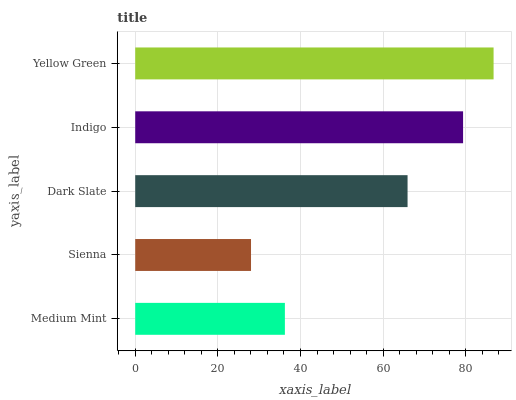Is Sienna the minimum?
Answer yes or no. Yes. Is Yellow Green the maximum?
Answer yes or no. Yes. Is Dark Slate the minimum?
Answer yes or no. No. Is Dark Slate the maximum?
Answer yes or no. No. Is Dark Slate greater than Sienna?
Answer yes or no. Yes. Is Sienna less than Dark Slate?
Answer yes or no. Yes. Is Sienna greater than Dark Slate?
Answer yes or no. No. Is Dark Slate less than Sienna?
Answer yes or no. No. Is Dark Slate the high median?
Answer yes or no. Yes. Is Dark Slate the low median?
Answer yes or no. Yes. Is Medium Mint the high median?
Answer yes or no. No. Is Sienna the low median?
Answer yes or no. No. 